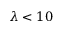<formula> <loc_0><loc_0><loc_500><loc_500>\lambda < 1 0</formula> 